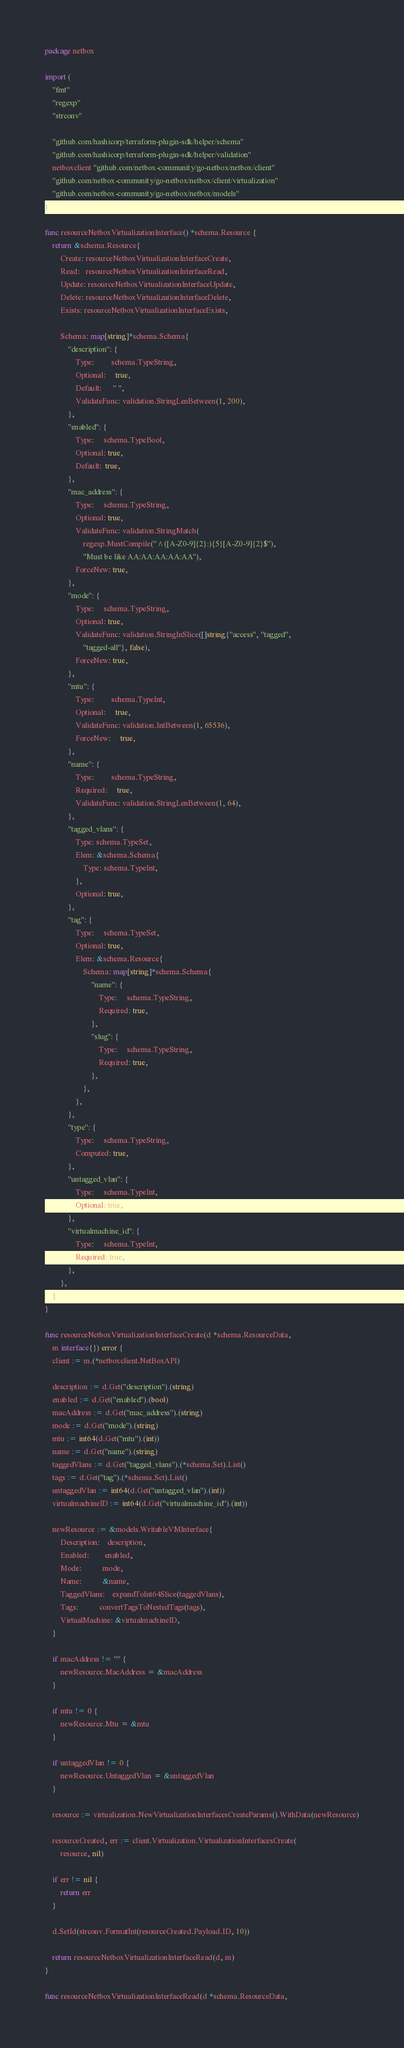<code> <loc_0><loc_0><loc_500><loc_500><_Go_>package netbox

import (
	"fmt"
	"regexp"
	"strconv"

	"github.com/hashicorp/terraform-plugin-sdk/helper/schema"
	"github.com/hashicorp/terraform-plugin-sdk/helper/validation"
	netboxclient "github.com/netbox-community/go-netbox/netbox/client"
	"github.com/netbox-community/go-netbox/netbox/client/virtualization"
	"github.com/netbox-community/go-netbox/netbox/models"
)

func resourceNetboxVirtualizationInterface() *schema.Resource {
	return &schema.Resource{
		Create: resourceNetboxVirtualizationInterfaceCreate,
		Read:   resourceNetboxVirtualizationInterfaceRead,
		Update: resourceNetboxVirtualizationInterfaceUpdate,
		Delete: resourceNetboxVirtualizationInterfaceDelete,
		Exists: resourceNetboxVirtualizationInterfaceExists,

		Schema: map[string]*schema.Schema{
			"description": {
				Type:         schema.TypeString,
				Optional:     true,
				Default:      " ",
				ValidateFunc: validation.StringLenBetween(1, 200),
			},
			"enabled": {
				Type:     schema.TypeBool,
				Optional: true,
				Default:  true,
			},
			"mac_address": {
				Type:     schema.TypeString,
				Optional: true,
				ValidateFunc: validation.StringMatch(
					regexp.MustCompile("^([A-Z0-9]{2}:){5}[A-Z0-9]{2}$"),
					"Must be like AA:AA:AA:AA:AA"),
				ForceNew: true,
			},
			"mode": {
				Type:     schema.TypeString,
				Optional: true,
				ValidateFunc: validation.StringInSlice([]string{"access", "tagged",
					"tagged-all"}, false),
				ForceNew: true,
			},
			"mtu": {
				Type:         schema.TypeInt,
				Optional:     true,
				ValidateFunc: validation.IntBetween(1, 65536),
				ForceNew:     true,
			},
			"name": {
				Type:         schema.TypeString,
				Required:     true,
				ValidateFunc: validation.StringLenBetween(1, 64),
			},
			"tagged_vlans": {
				Type: schema.TypeSet,
				Elem: &schema.Schema{
					Type: schema.TypeInt,
				},
				Optional: true,
			},
			"tag": {
				Type:     schema.TypeSet,
				Optional: true,
				Elem: &schema.Resource{
					Schema: map[string]*schema.Schema{
						"name": {
							Type:     schema.TypeString,
							Required: true,
						},
						"slug": {
							Type:     schema.TypeString,
							Required: true,
						},
					},
				},
			},
			"type": {
				Type:     schema.TypeString,
				Computed: true,
			},
			"untagged_vlan": {
				Type:     schema.TypeInt,
				Optional: true,
			},
			"virtualmachine_id": {
				Type:     schema.TypeInt,
				Required: true,
			},
		},
	}
}

func resourceNetboxVirtualizationInterfaceCreate(d *schema.ResourceData,
	m interface{}) error {
	client := m.(*netboxclient.NetBoxAPI)

	description := d.Get("description").(string)
	enabled := d.Get("enabled").(bool)
	macAddress := d.Get("mac_address").(string)
	mode := d.Get("mode").(string)
	mtu := int64(d.Get("mtu").(int))
	name := d.Get("name").(string)
	taggedVlans := d.Get("tagged_vlans").(*schema.Set).List()
	tags := d.Get("tag").(*schema.Set).List()
	untaggedVlan := int64(d.Get("untagged_vlan").(int))
	virtualmachineID := int64(d.Get("virtualmachine_id").(int))

	newResource := &models.WritableVMInterface{
		Description:    description,
		Enabled:        enabled,
		Mode:           mode,
		Name:           &name,
		TaggedVlans:    expandToInt64Slice(taggedVlans),
		Tags:           convertTagsToNestedTags(tags),
		VirtualMachine: &virtualmachineID,
	}

	if macAddress != "" {
		newResource.MacAddress = &macAddress
	}

	if mtu != 0 {
		newResource.Mtu = &mtu
	}

	if untaggedVlan != 0 {
		newResource.UntaggedVlan = &untaggedVlan
	}

	resource := virtualization.NewVirtualizationInterfacesCreateParams().WithData(newResource)

	resourceCreated, err := client.Virtualization.VirtualizationInterfacesCreate(
		resource, nil)

	if err != nil {
		return err
	}

	d.SetId(strconv.FormatInt(resourceCreated.Payload.ID, 10))

	return resourceNetboxVirtualizationInterfaceRead(d, m)
}

func resourceNetboxVirtualizationInterfaceRead(d *schema.ResourceData,</code> 